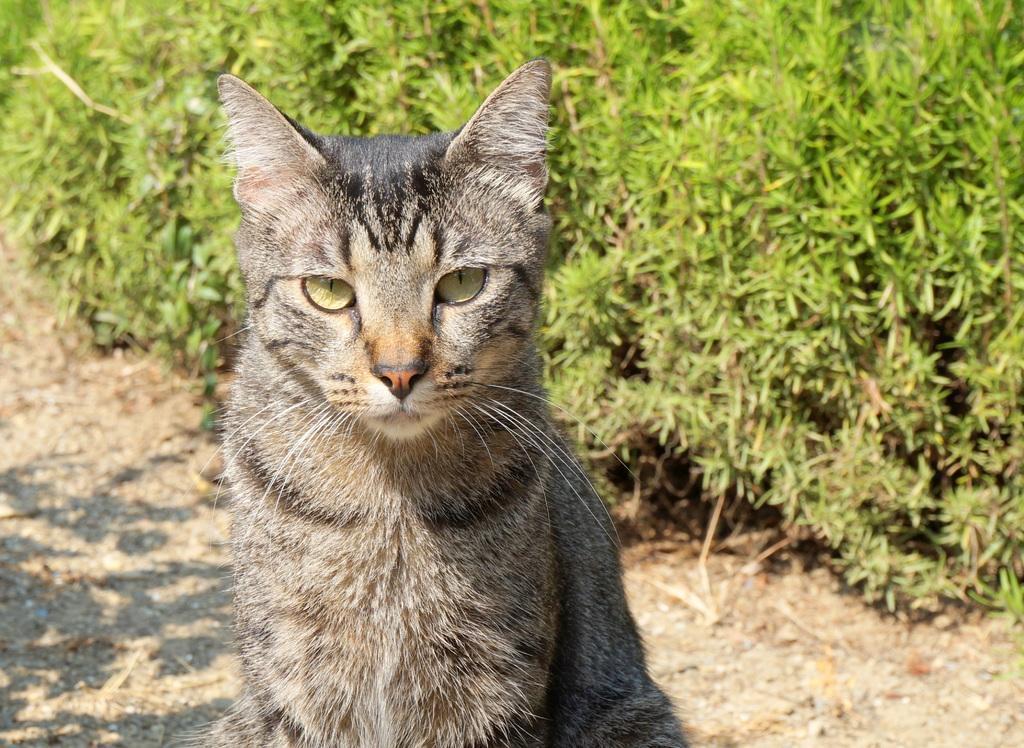In one or two sentences, can you explain what this image depicts? In this image we can see a cat. There are many plants in the image. 